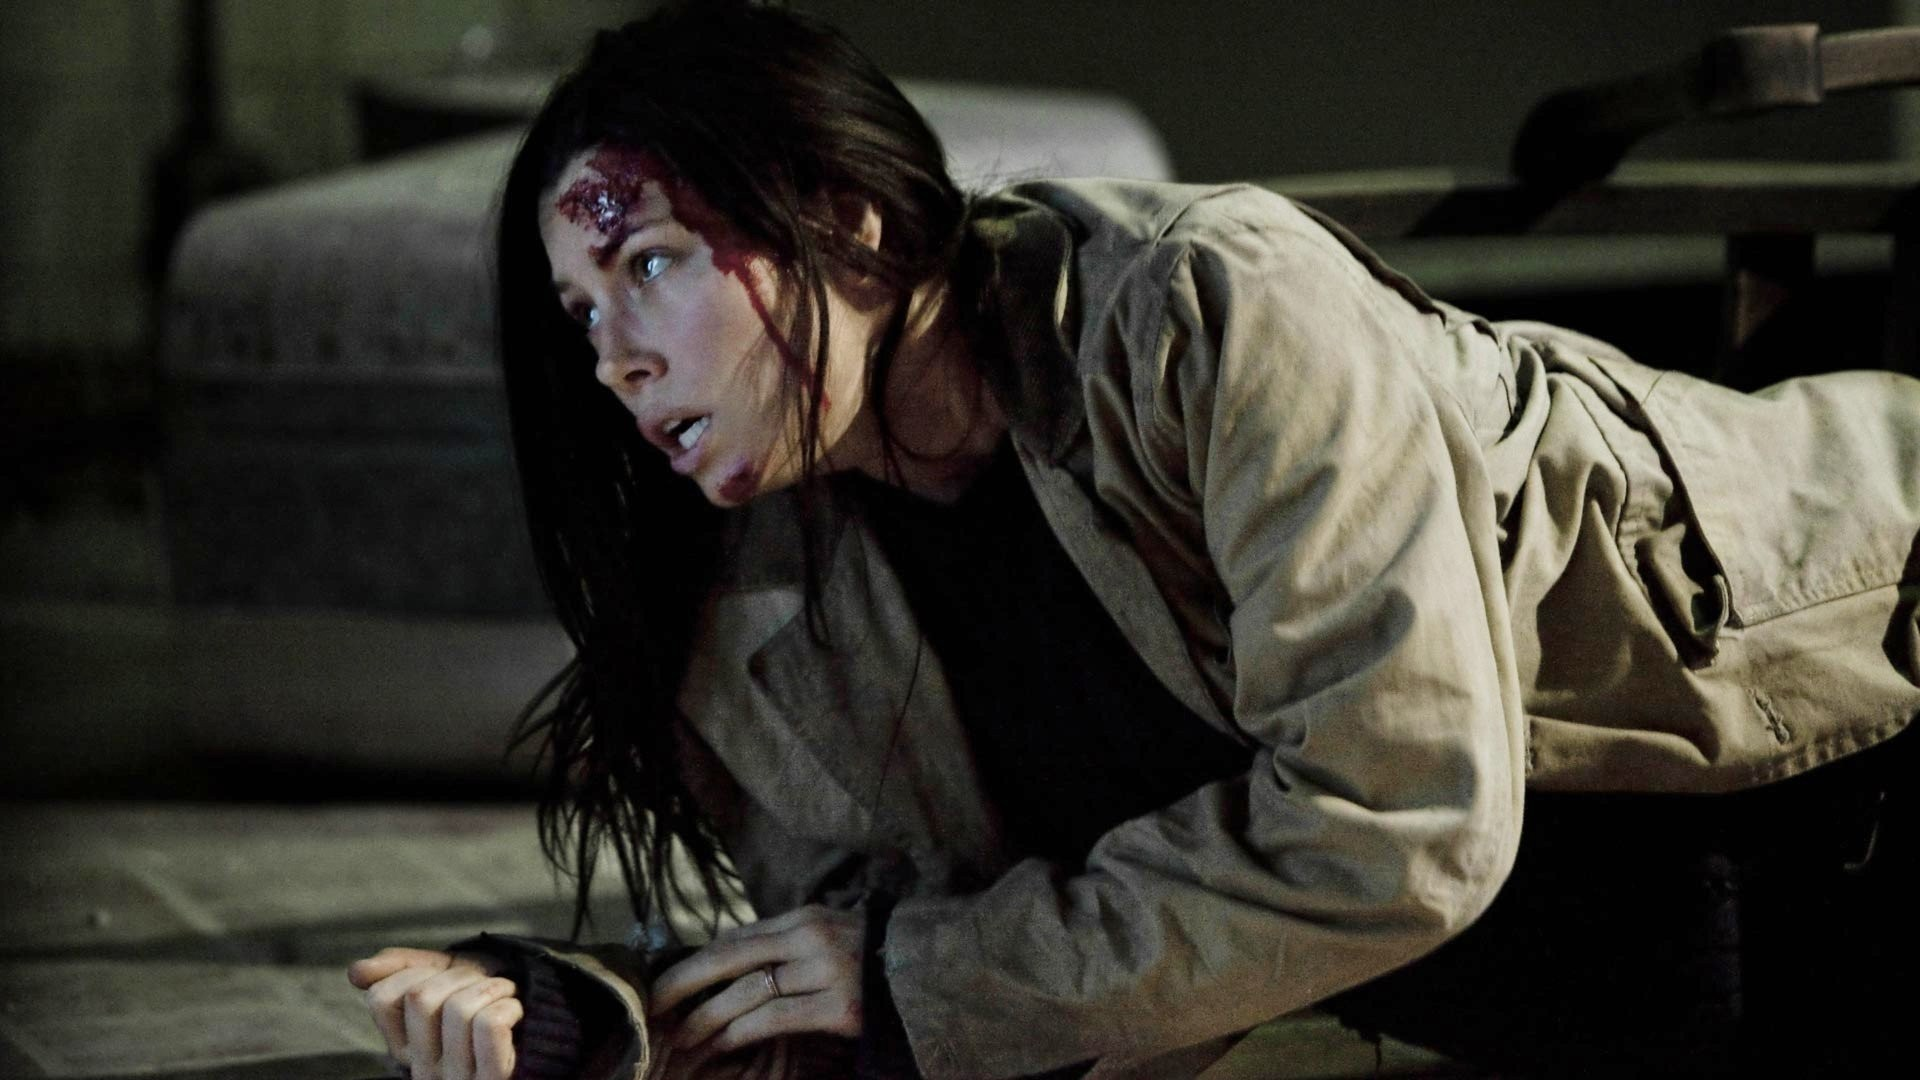Suppose this is a scene from a supernatural thriller. What supernatural elements are influencing the scene? In a supernatural thriller context, the woman in the image might be a paranormal investigator who has unintentionally summoned a vengeful spirit. The warehouse where she is crawling is haunted, and she has been physically attacked by the unseen entity. The bloody wound on her forehead could have been caused by a sudden invisble force. The dim lighting and eerie atmosphere amplify the terror, with ghostly whispers and unnerving sounds filling the air. She is desperately trying to escape the supernatural grasp, knowing that leaving the haunted premises might be her only chance for survival. What if the warehouse in the image hides a portal to another dimension? If the warehouse houses a portal to another dimension, the woman depicted might be an explorer or an agent investigating anomalies reported in this abandoned place. The portal, hidden somewhere within this industrial setup, leads to a chaotic and dangerous world. Her wound could be from an encounter with interdimensional creatures or due to the disruptive energy field emanated by the portal. As she crawls, she might be reaching for a device that can close the portal or stabilize the situation. The sense of danger is amplified by the unknown threats lurking just a dimension away, and time is of the essence to prevent catastrophic consequences for both worlds. 